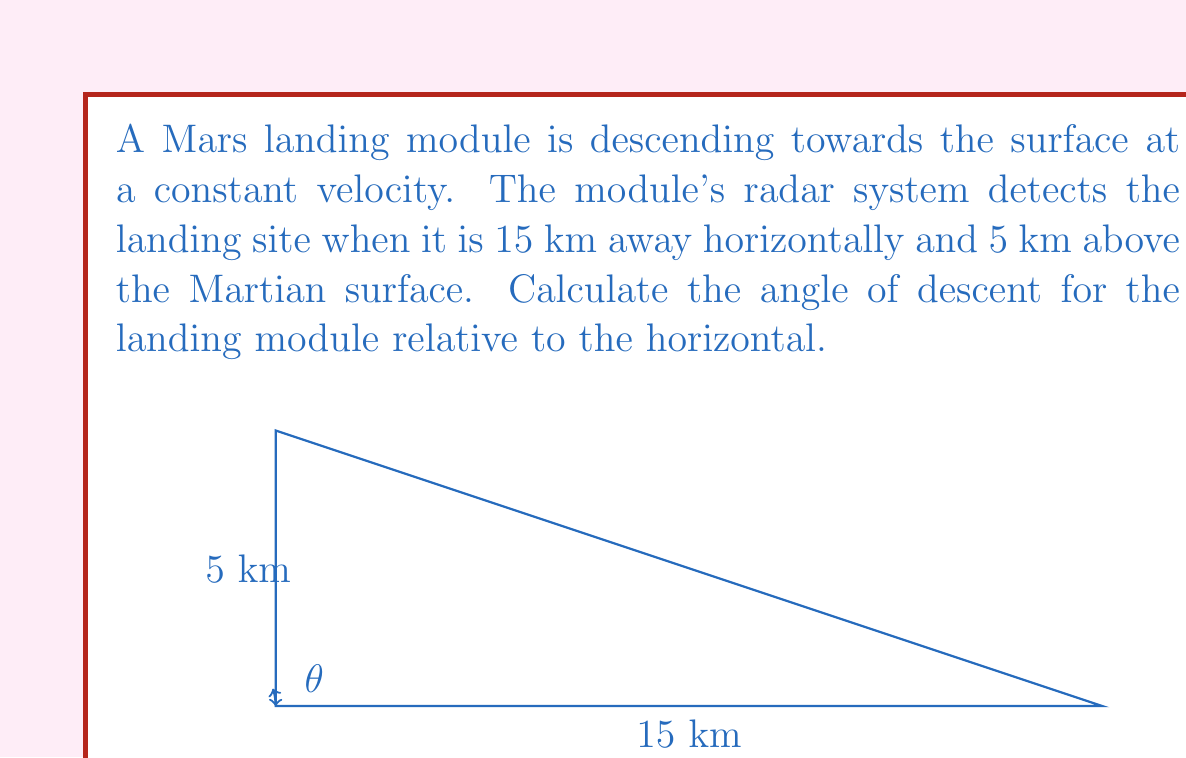Provide a solution to this math problem. To solve this problem, we can use trigonometry in the right-angled triangle formed by the landing module's path and the surface of Mars. Let's approach this step-by-step:

1) We have a right-angled triangle where:
   - The base (horizontal distance) is 15 km
   - The height (vertical distance) is 5 km
   - The hypotenuse is the path of the landing module
   - The angle we're looking for is the angle of descent, $\theta$

2) In a right-angled triangle, tangent of an angle is the ratio of the opposite side to the adjacent side:

   $$\tan(\theta) = \frac{\text{opposite}}{\text{adjacent}} = \frac{\text{height}}{\text{base}}$$

3) Substituting our known values:

   $$\tan(\theta) = \frac{5 \text{ km}}{15 \text{ km}} = \frac{1}{3}$$

4) To find $\theta$, we need to take the inverse tangent (arctangent) of both sides:

   $$\theta = \tan^{-1}(\frac{1}{3})$$

5) Using a calculator or trigonometric tables:

   $$\theta \approx 18.43^\circ$$

Therefore, the angle of descent for the landing module is approximately 18.43° relative to the horizontal.
Answer: $18.43^\circ$ 